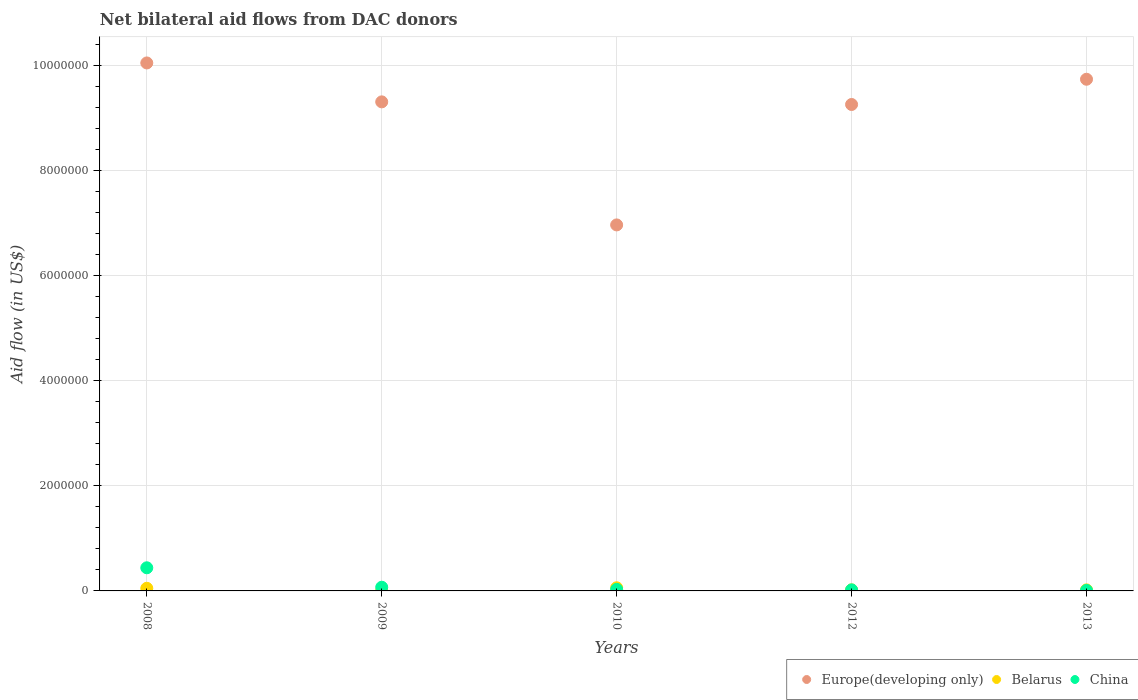How many different coloured dotlines are there?
Ensure brevity in your answer.  3. Is the number of dotlines equal to the number of legend labels?
Your answer should be very brief. Yes. Across all years, what is the maximum net bilateral aid flow in Europe(developing only)?
Provide a short and direct response. 1.00e+07. In which year was the net bilateral aid flow in Europe(developing only) maximum?
Give a very brief answer. 2008. What is the total net bilateral aid flow in China in the graph?
Your response must be concise. 5.70e+05. What is the difference between the net bilateral aid flow in China in 2008 and that in 2009?
Make the answer very short. 3.70e+05. What is the average net bilateral aid flow in Belarus per year?
Keep it short and to the point. 3.20e+04. In the year 2009, what is the difference between the net bilateral aid flow in Europe(developing only) and net bilateral aid flow in China?
Keep it short and to the point. 9.23e+06. In how many years, is the net bilateral aid flow in Belarus greater than 9200000 US$?
Make the answer very short. 0. What is the difference between the highest and the lowest net bilateral aid flow in China?
Give a very brief answer. 4.30e+05. In how many years, is the net bilateral aid flow in Europe(developing only) greater than the average net bilateral aid flow in Europe(developing only) taken over all years?
Offer a terse response. 4. Is the sum of the net bilateral aid flow in Belarus in 2008 and 2012 greater than the maximum net bilateral aid flow in Europe(developing only) across all years?
Offer a terse response. No. Is it the case that in every year, the sum of the net bilateral aid flow in China and net bilateral aid flow in Europe(developing only)  is greater than the net bilateral aid flow in Belarus?
Your answer should be compact. Yes. Is the net bilateral aid flow in Belarus strictly less than the net bilateral aid flow in Europe(developing only) over the years?
Your response must be concise. Yes. Does the graph contain any zero values?
Your answer should be compact. No. Does the graph contain grids?
Keep it short and to the point. Yes. Where does the legend appear in the graph?
Offer a very short reply. Bottom right. How many legend labels are there?
Offer a very short reply. 3. What is the title of the graph?
Ensure brevity in your answer.  Net bilateral aid flows from DAC donors. Does "Germany" appear as one of the legend labels in the graph?
Ensure brevity in your answer.  No. What is the label or title of the Y-axis?
Your response must be concise. Aid flow (in US$). What is the Aid flow (in US$) in Europe(developing only) in 2008?
Give a very brief answer. 1.00e+07. What is the Aid flow (in US$) of Belarus in 2008?
Make the answer very short. 5.00e+04. What is the Aid flow (in US$) of Europe(developing only) in 2009?
Ensure brevity in your answer.  9.30e+06. What is the Aid flow (in US$) of Belarus in 2009?
Ensure brevity in your answer.  10000. What is the Aid flow (in US$) in Europe(developing only) in 2010?
Offer a very short reply. 6.96e+06. What is the Aid flow (in US$) in China in 2010?
Offer a terse response. 3.00e+04. What is the Aid flow (in US$) of Europe(developing only) in 2012?
Provide a succinct answer. 9.25e+06. What is the Aid flow (in US$) in Belarus in 2012?
Your response must be concise. 2.00e+04. What is the Aid flow (in US$) in Europe(developing only) in 2013?
Your answer should be compact. 9.73e+06. Across all years, what is the maximum Aid flow (in US$) of Europe(developing only)?
Ensure brevity in your answer.  1.00e+07. Across all years, what is the maximum Aid flow (in US$) of Belarus?
Offer a very short reply. 6.00e+04. Across all years, what is the maximum Aid flow (in US$) in China?
Give a very brief answer. 4.40e+05. Across all years, what is the minimum Aid flow (in US$) in Europe(developing only)?
Keep it short and to the point. 6.96e+06. Across all years, what is the minimum Aid flow (in US$) in Belarus?
Make the answer very short. 10000. Across all years, what is the minimum Aid flow (in US$) of China?
Your answer should be very brief. 10000. What is the total Aid flow (in US$) in Europe(developing only) in the graph?
Your response must be concise. 4.53e+07. What is the total Aid flow (in US$) of Belarus in the graph?
Keep it short and to the point. 1.60e+05. What is the total Aid flow (in US$) of China in the graph?
Your answer should be very brief. 5.70e+05. What is the difference between the Aid flow (in US$) of Europe(developing only) in 2008 and that in 2009?
Keep it short and to the point. 7.40e+05. What is the difference between the Aid flow (in US$) of Europe(developing only) in 2008 and that in 2010?
Your answer should be very brief. 3.08e+06. What is the difference between the Aid flow (in US$) of Belarus in 2008 and that in 2010?
Provide a succinct answer. -10000. What is the difference between the Aid flow (in US$) of China in 2008 and that in 2010?
Keep it short and to the point. 4.10e+05. What is the difference between the Aid flow (in US$) of Europe(developing only) in 2008 and that in 2012?
Give a very brief answer. 7.90e+05. What is the difference between the Aid flow (in US$) in Belarus in 2008 and that in 2012?
Provide a short and direct response. 3.00e+04. What is the difference between the Aid flow (in US$) of Europe(developing only) in 2008 and that in 2013?
Make the answer very short. 3.10e+05. What is the difference between the Aid flow (in US$) of Belarus in 2008 and that in 2013?
Keep it short and to the point. 3.00e+04. What is the difference between the Aid flow (in US$) of China in 2008 and that in 2013?
Your answer should be very brief. 4.30e+05. What is the difference between the Aid flow (in US$) in Europe(developing only) in 2009 and that in 2010?
Make the answer very short. 2.34e+06. What is the difference between the Aid flow (in US$) of Belarus in 2009 and that in 2010?
Your answer should be compact. -5.00e+04. What is the difference between the Aid flow (in US$) in China in 2009 and that in 2010?
Make the answer very short. 4.00e+04. What is the difference between the Aid flow (in US$) of Europe(developing only) in 2009 and that in 2012?
Give a very brief answer. 5.00e+04. What is the difference between the Aid flow (in US$) in China in 2009 and that in 2012?
Make the answer very short. 5.00e+04. What is the difference between the Aid flow (in US$) in Europe(developing only) in 2009 and that in 2013?
Provide a short and direct response. -4.30e+05. What is the difference between the Aid flow (in US$) in Europe(developing only) in 2010 and that in 2012?
Offer a terse response. -2.29e+06. What is the difference between the Aid flow (in US$) in Europe(developing only) in 2010 and that in 2013?
Your answer should be compact. -2.77e+06. What is the difference between the Aid flow (in US$) of Belarus in 2010 and that in 2013?
Provide a succinct answer. 4.00e+04. What is the difference between the Aid flow (in US$) in Europe(developing only) in 2012 and that in 2013?
Your response must be concise. -4.80e+05. What is the difference between the Aid flow (in US$) in Europe(developing only) in 2008 and the Aid flow (in US$) in Belarus in 2009?
Your response must be concise. 1.00e+07. What is the difference between the Aid flow (in US$) in Europe(developing only) in 2008 and the Aid flow (in US$) in China in 2009?
Offer a very short reply. 9.97e+06. What is the difference between the Aid flow (in US$) of Belarus in 2008 and the Aid flow (in US$) of China in 2009?
Ensure brevity in your answer.  -2.00e+04. What is the difference between the Aid flow (in US$) of Europe(developing only) in 2008 and the Aid flow (in US$) of Belarus in 2010?
Offer a very short reply. 9.98e+06. What is the difference between the Aid flow (in US$) of Europe(developing only) in 2008 and the Aid flow (in US$) of China in 2010?
Offer a very short reply. 1.00e+07. What is the difference between the Aid flow (in US$) in Belarus in 2008 and the Aid flow (in US$) in China in 2010?
Your answer should be compact. 2.00e+04. What is the difference between the Aid flow (in US$) in Europe(developing only) in 2008 and the Aid flow (in US$) in Belarus in 2012?
Provide a succinct answer. 1.00e+07. What is the difference between the Aid flow (in US$) of Europe(developing only) in 2008 and the Aid flow (in US$) of China in 2012?
Your answer should be very brief. 1.00e+07. What is the difference between the Aid flow (in US$) in Europe(developing only) in 2008 and the Aid flow (in US$) in Belarus in 2013?
Your answer should be compact. 1.00e+07. What is the difference between the Aid flow (in US$) of Europe(developing only) in 2008 and the Aid flow (in US$) of China in 2013?
Keep it short and to the point. 1.00e+07. What is the difference between the Aid flow (in US$) of Europe(developing only) in 2009 and the Aid flow (in US$) of Belarus in 2010?
Provide a short and direct response. 9.24e+06. What is the difference between the Aid flow (in US$) in Europe(developing only) in 2009 and the Aid flow (in US$) in China in 2010?
Offer a very short reply. 9.27e+06. What is the difference between the Aid flow (in US$) of Europe(developing only) in 2009 and the Aid flow (in US$) of Belarus in 2012?
Provide a short and direct response. 9.28e+06. What is the difference between the Aid flow (in US$) in Europe(developing only) in 2009 and the Aid flow (in US$) in China in 2012?
Provide a short and direct response. 9.28e+06. What is the difference between the Aid flow (in US$) in Belarus in 2009 and the Aid flow (in US$) in China in 2012?
Offer a terse response. -10000. What is the difference between the Aid flow (in US$) of Europe(developing only) in 2009 and the Aid flow (in US$) of Belarus in 2013?
Give a very brief answer. 9.28e+06. What is the difference between the Aid flow (in US$) in Europe(developing only) in 2009 and the Aid flow (in US$) in China in 2013?
Ensure brevity in your answer.  9.29e+06. What is the difference between the Aid flow (in US$) of Europe(developing only) in 2010 and the Aid flow (in US$) of Belarus in 2012?
Make the answer very short. 6.94e+06. What is the difference between the Aid flow (in US$) in Europe(developing only) in 2010 and the Aid flow (in US$) in China in 2012?
Offer a very short reply. 6.94e+06. What is the difference between the Aid flow (in US$) in Europe(developing only) in 2010 and the Aid flow (in US$) in Belarus in 2013?
Keep it short and to the point. 6.94e+06. What is the difference between the Aid flow (in US$) in Europe(developing only) in 2010 and the Aid flow (in US$) in China in 2013?
Make the answer very short. 6.95e+06. What is the difference between the Aid flow (in US$) of Belarus in 2010 and the Aid flow (in US$) of China in 2013?
Give a very brief answer. 5.00e+04. What is the difference between the Aid flow (in US$) of Europe(developing only) in 2012 and the Aid flow (in US$) of Belarus in 2013?
Offer a terse response. 9.23e+06. What is the difference between the Aid flow (in US$) in Europe(developing only) in 2012 and the Aid flow (in US$) in China in 2013?
Give a very brief answer. 9.24e+06. What is the average Aid flow (in US$) of Europe(developing only) per year?
Provide a short and direct response. 9.06e+06. What is the average Aid flow (in US$) in Belarus per year?
Offer a terse response. 3.20e+04. What is the average Aid flow (in US$) of China per year?
Provide a succinct answer. 1.14e+05. In the year 2008, what is the difference between the Aid flow (in US$) of Europe(developing only) and Aid flow (in US$) of Belarus?
Your answer should be very brief. 9.99e+06. In the year 2008, what is the difference between the Aid flow (in US$) in Europe(developing only) and Aid flow (in US$) in China?
Keep it short and to the point. 9.60e+06. In the year 2008, what is the difference between the Aid flow (in US$) in Belarus and Aid flow (in US$) in China?
Offer a very short reply. -3.90e+05. In the year 2009, what is the difference between the Aid flow (in US$) of Europe(developing only) and Aid flow (in US$) of Belarus?
Offer a very short reply. 9.29e+06. In the year 2009, what is the difference between the Aid flow (in US$) in Europe(developing only) and Aid flow (in US$) in China?
Make the answer very short. 9.23e+06. In the year 2009, what is the difference between the Aid flow (in US$) in Belarus and Aid flow (in US$) in China?
Your response must be concise. -6.00e+04. In the year 2010, what is the difference between the Aid flow (in US$) in Europe(developing only) and Aid flow (in US$) in Belarus?
Keep it short and to the point. 6.90e+06. In the year 2010, what is the difference between the Aid flow (in US$) of Europe(developing only) and Aid flow (in US$) of China?
Provide a short and direct response. 6.93e+06. In the year 2012, what is the difference between the Aid flow (in US$) in Europe(developing only) and Aid flow (in US$) in Belarus?
Offer a terse response. 9.23e+06. In the year 2012, what is the difference between the Aid flow (in US$) of Europe(developing only) and Aid flow (in US$) of China?
Offer a terse response. 9.23e+06. In the year 2013, what is the difference between the Aid flow (in US$) in Europe(developing only) and Aid flow (in US$) in Belarus?
Make the answer very short. 9.71e+06. In the year 2013, what is the difference between the Aid flow (in US$) of Europe(developing only) and Aid flow (in US$) of China?
Your answer should be compact. 9.72e+06. What is the ratio of the Aid flow (in US$) of Europe(developing only) in 2008 to that in 2009?
Make the answer very short. 1.08. What is the ratio of the Aid flow (in US$) in China in 2008 to that in 2009?
Keep it short and to the point. 6.29. What is the ratio of the Aid flow (in US$) of Europe(developing only) in 2008 to that in 2010?
Give a very brief answer. 1.44. What is the ratio of the Aid flow (in US$) in China in 2008 to that in 2010?
Ensure brevity in your answer.  14.67. What is the ratio of the Aid flow (in US$) in Europe(developing only) in 2008 to that in 2012?
Ensure brevity in your answer.  1.09. What is the ratio of the Aid flow (in US$) of Europe(developing only) in 2008 to that in 2013?
Your answer should be very brief. 1.03. What is the ratio of the Aid flow (in US$) in Europe(developing only) in 2009 to that in 2010?
Your answer should be very brief. 1.34. What is the ratio of the Aid flow (in US$) of China in 2009 to that in 2010?
Your answer should be very brief. 2.33. What is the ratio of the Aid flow (in US$) in Europe(developing only) in 2009 to that in 2012?
Your answer should be very brief. 1.01. What is the ratio of the Aid flow (in US$) in Belarus in 2009 to that in 2012?
Your response must be concise. 0.5. What is the ratio of the Aid flow (in US$) in China in 2009 to that in 2012?
Ensure brevity in your answer.  3.5. What is the ratio of the Aid flow (in US$) in Europe(developing only) in 2009 to that in 2013?
Offer a terse response. 0.96. What is the ratio of the Aid flow (in US$) of Belarus in 2009 to that in 2013?
Your answer should be very brief. 0.5. What is the ratio of the Aid flow (in US$) of China in 2009 to that in 2013?
Offer a very short reply. 7. What is the ratio of the Aid flow (in US$) of Europe(developing only) in 2010 to that in 2012?
Make the answer very short. 0.75. What is the ratio of the Aid flow (in US$) in Belarus in 2010 to that in 2012?
Provide a short and direct response. 3. What is the ratio of the Aid flow (in US$) of China in 2010 to that in 2012?
Your response must be concise. 1.5. What is the ratio of the Aid flow (in US$) in Europe(developing only) in 2010 to that in 2013?
Your answer should be compact. 0.72. What is the ratio of the Aid flow (in US$) in Belarus in 2010 to that in 2013?
Offer a terse response. 3. What is the ratio of the Aid flow (in US$) in Europe(developing only) in 2012 to that in 2013?
Your answer should be compact. 0.95. What is the ratio of the Aid flow (in US$) in Belarus in 2012 to that in 2013?
Offer a very short reply. 1. What is the ratio of the Aid flow (in US$) in China in 2012 to that in 2013?
Ensure brevity in your answer.  2. What is the difference between the highest and the second highest Aid flow (in US$) of Europe(developing only)?
Your answer should be very brief. 3.10e+05. What is the difference between the highest and the second highest Aid flow (in US$) of Belarus?
Provide a short and direct response. 10000. What is the difference between the highest and the second highest Aid flow (in US$) of China?
Your answer should be compact. 3.70e+05. What is the difference between the highest and the lowest Aid flow (in US$) of Europe(developing only)?
Offer a terse response. 3.08e+06. What is the difference between the highest and the lowest Aid flow (in US$) in Belarus?
Give a very brief answer. 5.00e+04. 